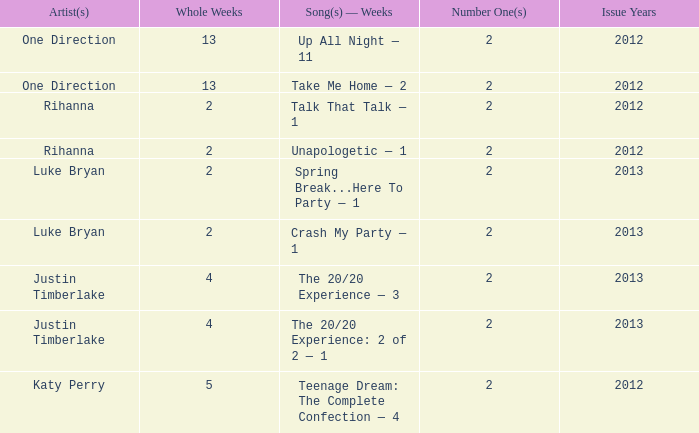What is the longest number of weeks any 1 song was at number #1? 13.0. 